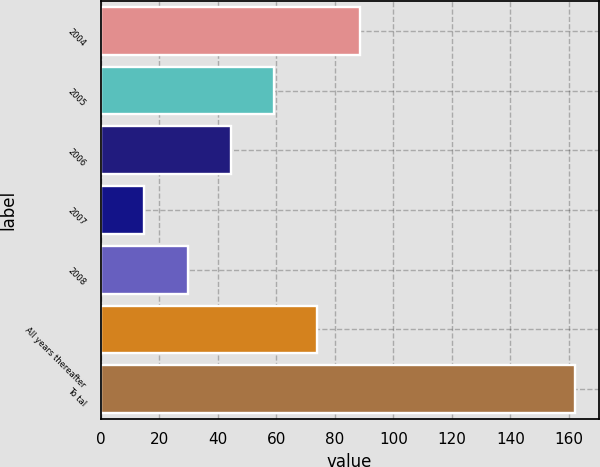<chart> <loc_0><loc_0><loc_500><loc_500><bar_chart><fcel>2004<fcel>2005<fcel>2006<fcel>2007<fcel>2008<fcel>All years thereafter<fcel>To tal<nl><fcel>88.5<fcel>59.1<fcel>44.4<fcel>15<fcel>29.7<fcel>73.8<fcel>162<nl></chart> 